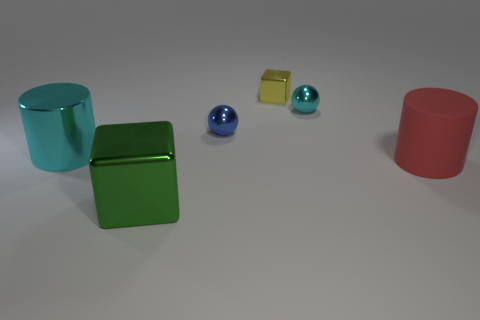Add 2 large blue matte cylinders. How many objects exist? 8 Subtract all blocks. How many objects are left? 4 Add 2 small things. How many small things are left? 5 Add 4 gray spheres. How many gray spheres exist? 4 Subtract 0 purple cylinders. How many objects are left? 6 Subtract all green metal cubes. Subtract all big metal cubes. How many objects are left? 4 